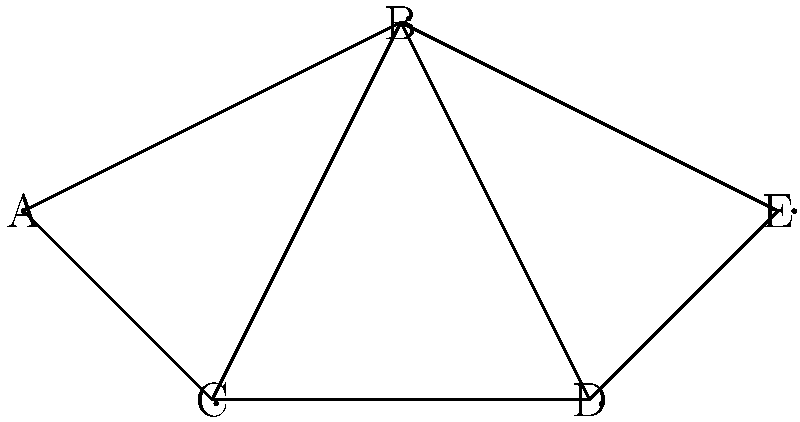In a project management network, tasks are represented as nodes, and dependencies between tasks are represented as edges. To optimize resource allocation, we need to color the graph such that no two adjacent nodes have the same color, using the minimum number of colors possible. This allows us to group tasks that can be performed simultaneously.

Given the project network shown in the diagram, what is the minimum number of colors needed to properly color the graph, and what does this number represent in terms of project resources? To solve this graph coloring problem and optimize resource allocation, we'll follow these steps:

1. Analyze the graph structure:
   The graph has 5 nodes (A, B, C, D, E) representing tasks.
   Edges between nodes represent dependencies or conflicts between tasks.

2. Apply the graph coloring algorithm:
   Start with node A and assign it color 1.
   Move to adjacent nodes and assign different colors:
   - B: color 2
   - C: color 2 (can't be color 1 due to connection with A)
   Now, color the remaining nodes:
   - D: color 1 (connected to B and C, which are both color 2)
   - E: color 3 (connected to B and D, which are colors 2 and 1)

3. Count the minimum number of colors used:
   We used 3 colors to properly color the graph.

4. Interpret the result:
   The minimum number of colors (3) represents the minimum number of distinct resource groups or time slots needed to complete all tasks without conflicts.
   Tasks with the same color can be performed simultaneously or by the same resource group.

5. Resource allocation interpretation:
   - Color 1 tasks (A and D) can be performed in the first time slot or by resource group 1.
   - Color 2 tasks (B and C) can be performed in the second time slot or by resource group 2.
   - Color 3 task (E) needs to be performed in a third time slot or by resource group 3.

This coloring ensures that no dependent or conflicting tasks are scheduled simultaneously, optimizing resource usage and project timeline.
Answer: 3 colors; minimum number of distinct resource groups or time slots 